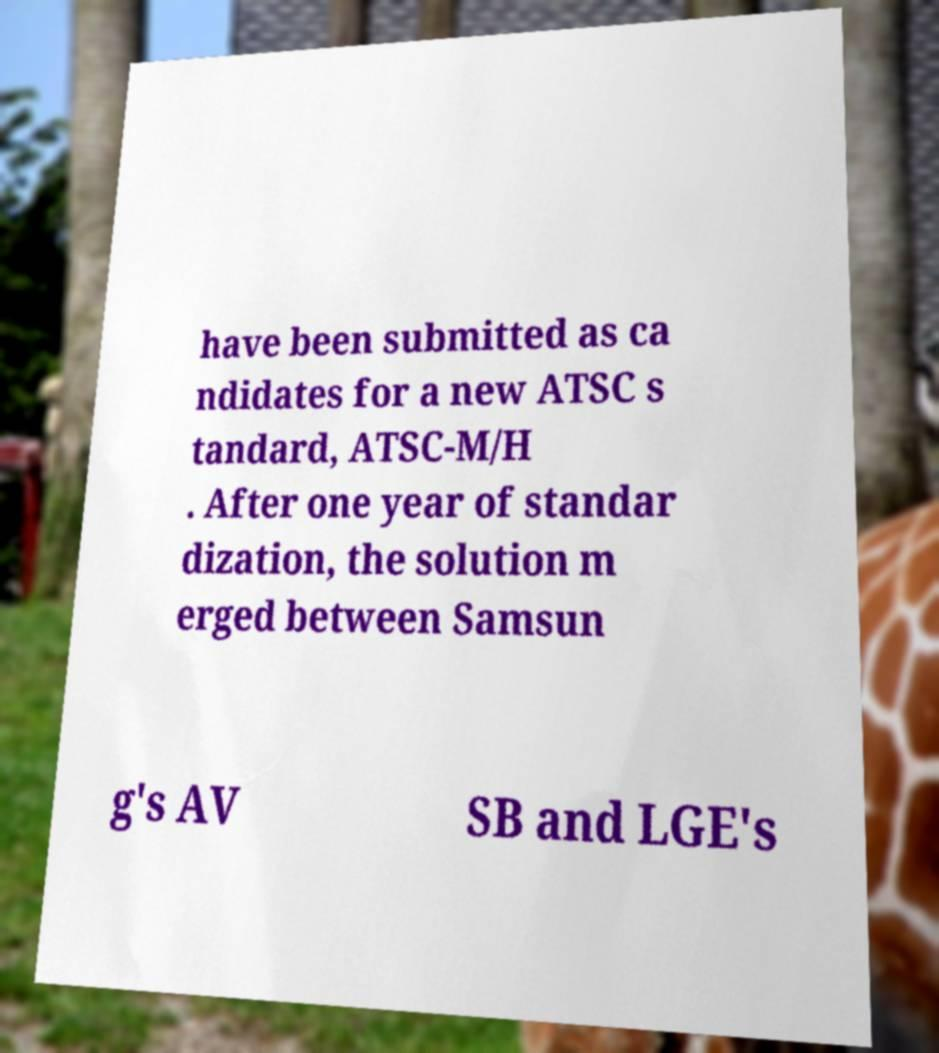What messages or text are displayed in this image? I need them in a readable, typed format. have been submitted as ca ndidates for a new ATSC s tandard, ATSC-M/H . After one year of standar dization, the solution m erged between Samsun g's AV SB and LGE's 